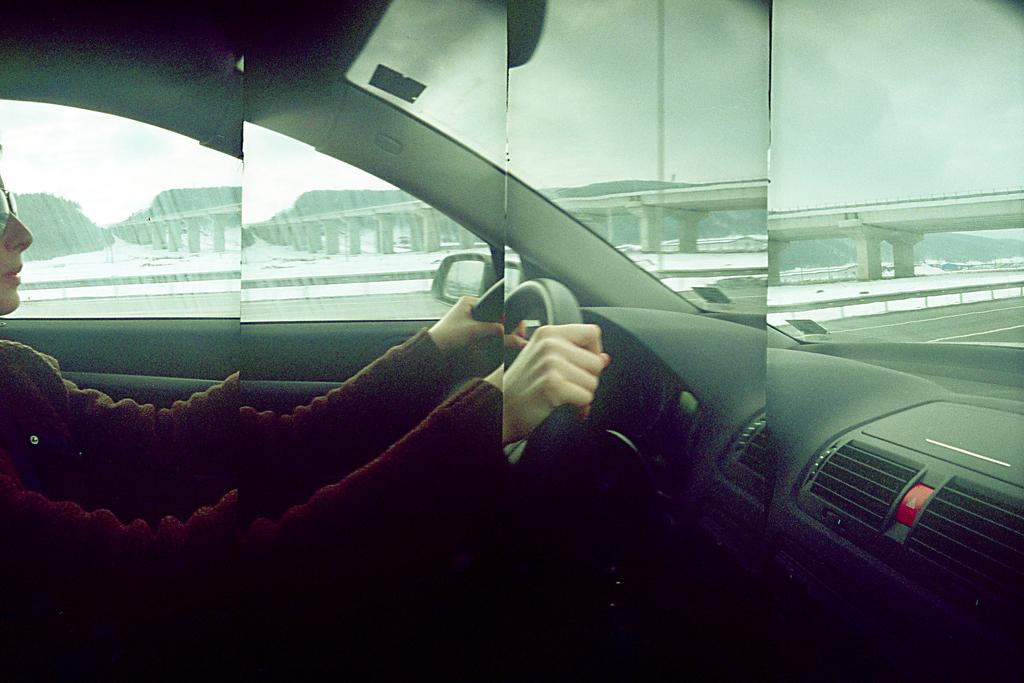What type of picture is shown in the image? There is a collage picture in the image. What is the woman in the collage picture doing? The collage picture contains an image of a woman riding a vehicle. What can be seen in the background of the collage picture? There is a bridge and hills visible in the background of the collage picture. Where is the wrench placed in the image? There is no wrench present in the image. What type of crib can be seen in the image? There is no crib present in the image. 